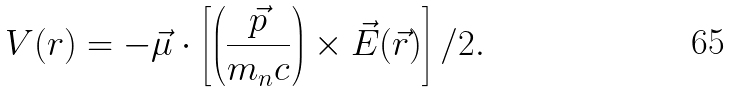<formula> <loc_0><loc_0><loc_500><loc_500>V ( r ) = - \vec { \mu } \cdot \left [ \left ( { \frac { \vec { p } } { m _ { n } c } } \right ) \times \vec { E } ( \vec { r } ) \right ] / 2 .</formula> 